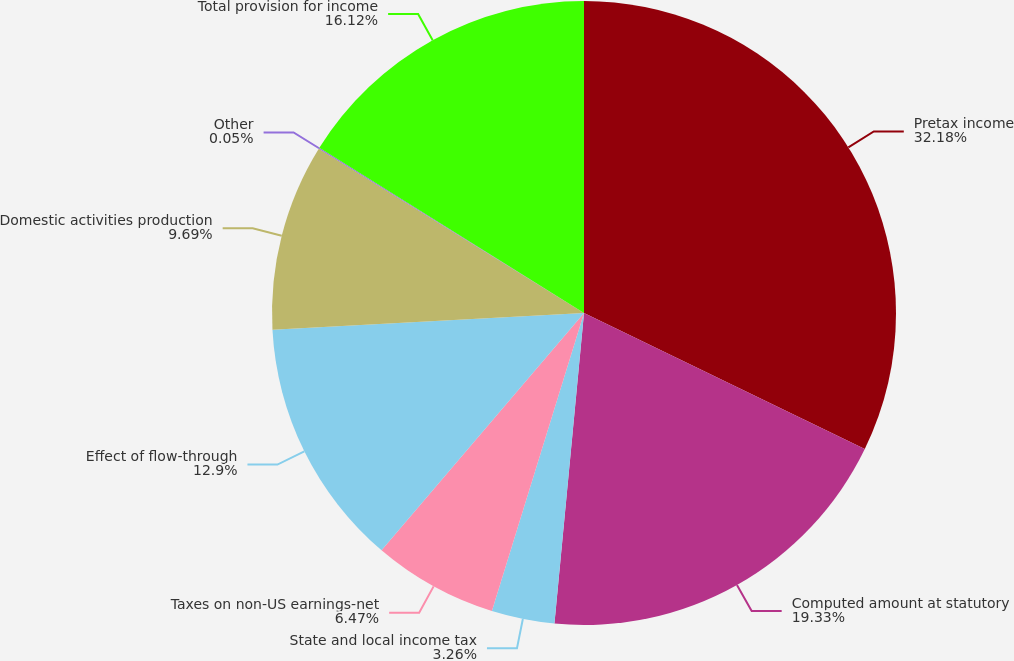<chart> <loc_0><loc_0><loc_500><loc_500><pie_chart><fcel>Pretax income<fcel>Computed amount at statutory<fcel>State and local income tax<fcel>Taxes on non-US earnings-net<fcel>Effect of flow-through<fcel>Domestic activities production<fcel>Other<fcel>Total provision for income<nl><fcel>32.18%<fcel>19.33%<fcel>3.26%<fcel>6.47%<fcel>12.9%<fcel>9.69%<fcel>0.05%<fcel>16.12%<nl></chart> 